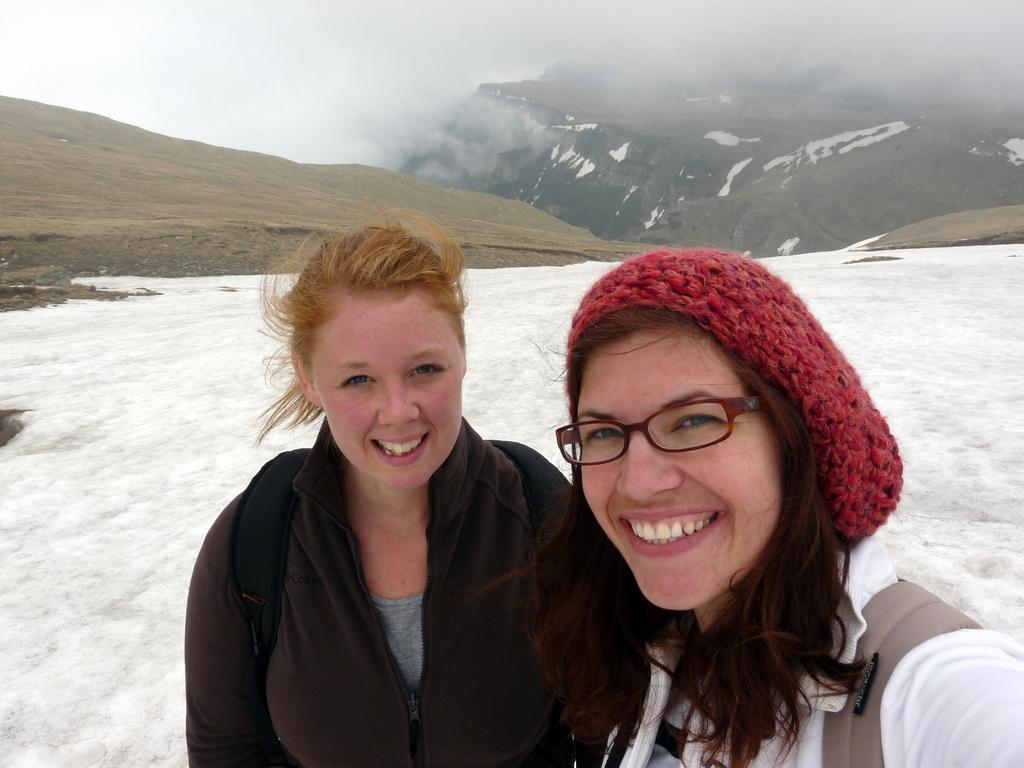Who are the main subjects in the image? There are two girls in the center of the image. What is the ground made of in the image? There is snow at the bottom side of the image. What can be seen in the background of the image? There are mountains at the top side of the image. What type of test is being conducted by the birds in the image? There are no birds present in the image, so no test is being conducted. 